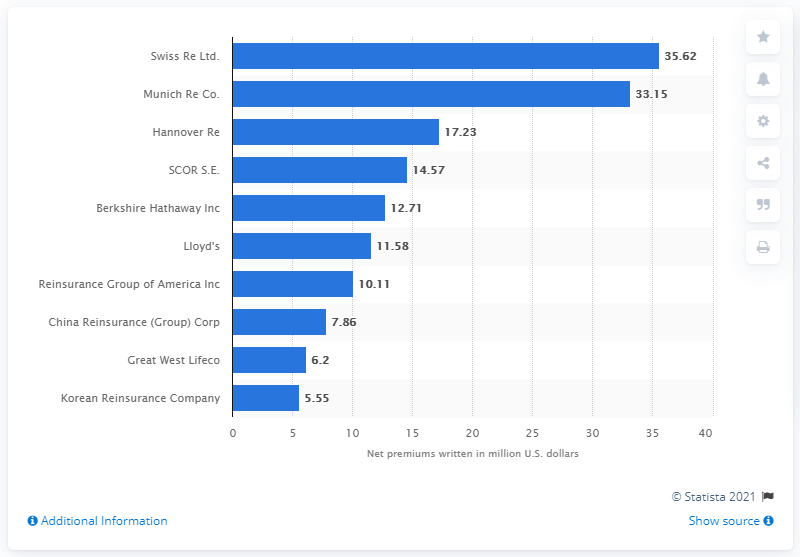Point out several critical features in this image. In 2016, the gross reinsurance premiums written by Hannover Re amounted to 17.23... 